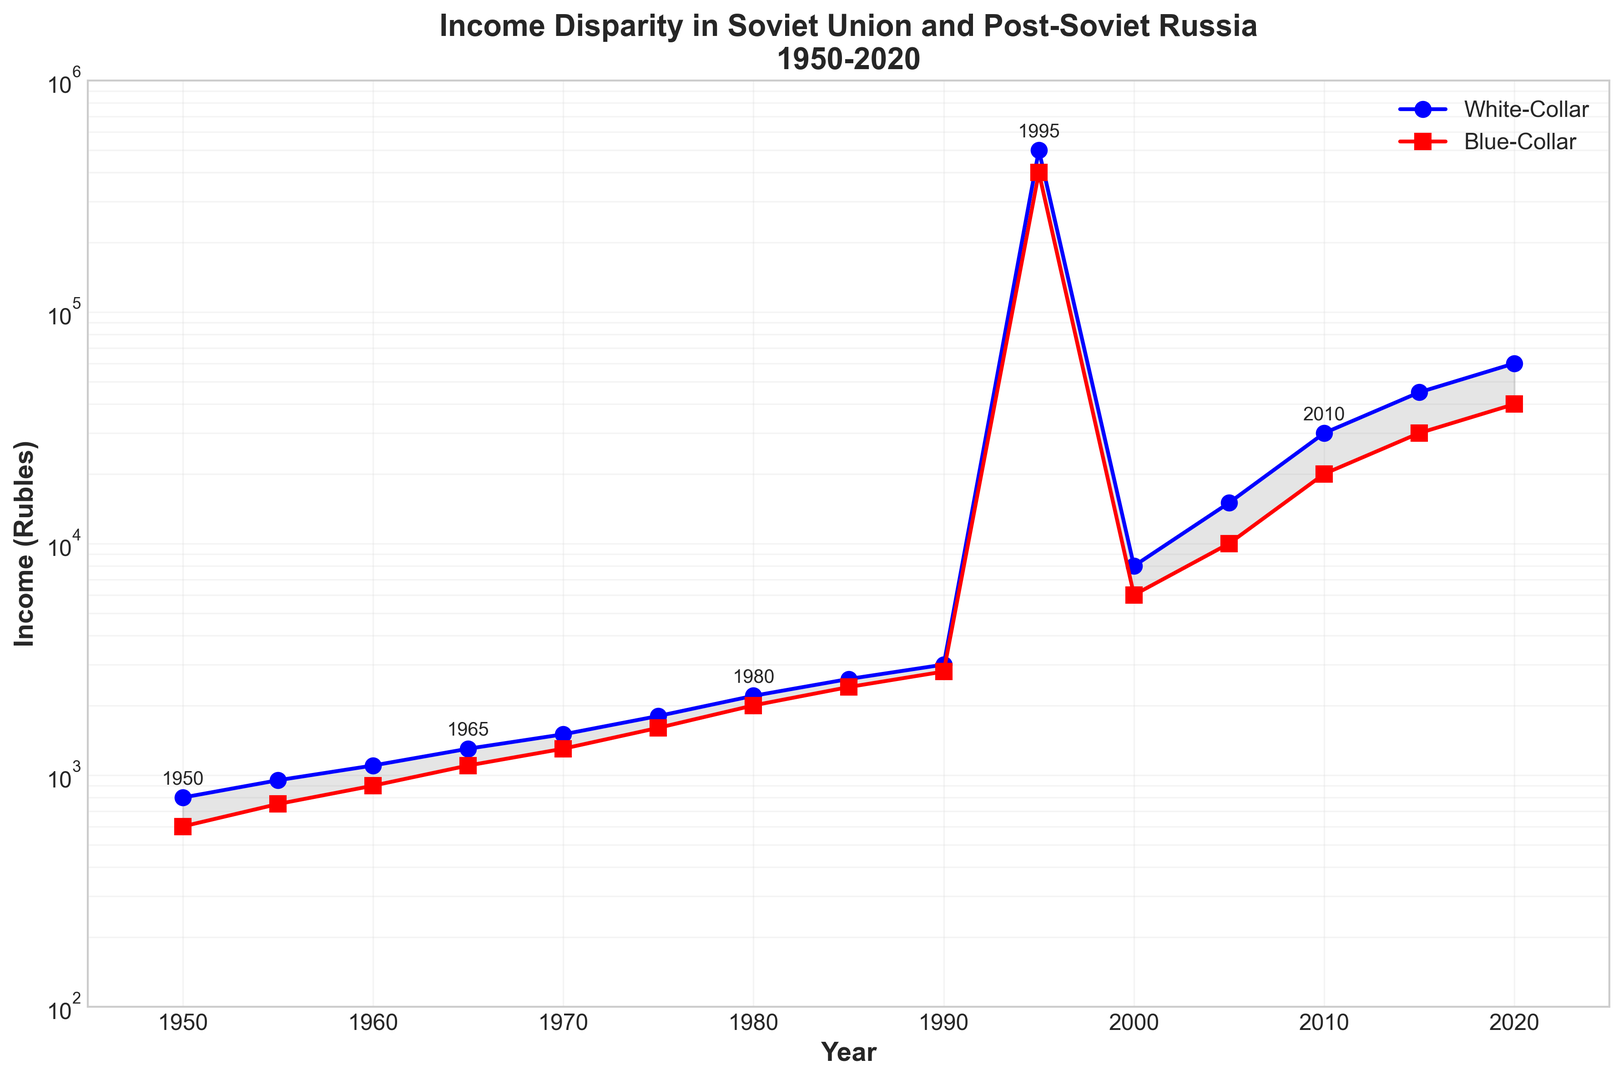What trends do you observe in the income disparity between white-collar and blue-collar workers from 1950 to 2020? The graph shows that both white-collar and blue-collar incomes increased over time, with a significant spike around 1995, coinciding with the post-Soviet era. Before 1995, the income disparity (difference between white-collar and blue-collar incomes) grew steadily but was relatively modest. After 1995, the income disparity widened much more significantly, indicating a larger gap between white-collar and blue-collar incomes in post-Soviet Russia.
Answer: The income disparity increased especially after 1995 During which period did the white-collar income see the most dramatic increase? By examining the slopes of the lines, the white-collar income saw the most dramatic increase between 1990 and 1995. This is indicated by the steep rise in the blue line (white-collar income) during this period.
Answer: 1990-1995 How much was the income disparity between white-collar and blue-collar workers in 2020? The white-collar income in 2020 was 60,000 rubles and the blue-collar income was 40,000 rubles. The income disparity is calculated as 60,000 - 40,000 = 20,000 rubles.
Answer: 20,000 rubles What was the ratio of white-collar to blue-collar income in 1970? The white-collar income in 1970 was 1500 rubles and the blue-collar income was 1300 rubles. The ratio is calculated as 1500 / 1300 ≈ 1.15.
Answer: 1.15 Identify the year with the smallest income disparity between white-collar and blue-collar workers. By observing the gap between the blue and red lines, the smallest disparity occurred in 1955, where the incomes were 950 rubles for white-collar and 750 rubles for blue-collar workers. The difference is 950 - 750 = 200 rubles.
Answer: 1955 How did the income of blue-collar workers change from 1980 to 2000? The blue-collar income in 1980 was 2000 rubles and in 2000 it was 6000 rubles. The change can be calculated as 6000 - 2000 = 4000 rubles.
Answer: Increased by 4000 rubles Compare the percentage increase in white-collar income to blue-collar income from 2015 to 2020. The white-collar income increased from 45000 to 60000 rubles, which is (60000-45000)/45000 * 100 ≈ 33.33%. The blue-collar income increased from 30000 to 40000 rubles, which is (40000-30000)/30000 * 100 ≈ 33.33%. Both percentages are approximately the same.
Answer: 33.33% for both What visual elements help emphasize the income disparity on the graph? The fill between the two lines, the different colors (blue for white-collar and red for blue-collar), and the semilogarithmic scale help emphasize the income disparity. This highlight is a shaded area between the lines, clear color differentiation, and log scale to show larger disparities distinctly.
Answer: Fill between the lines, colors, log scale Is there any period where the income levels for both groups appear to remain relatively stable? Between 1950 and 1985, the incomes of both white-collar and blue-collar workers show a gradual and more stable rise compared to the steep increases observed post-1990. The lines are smoother with smaller increments during this earlier period.
Answer: 1950-1985 What can be inferred from the graph about how economic transitions affected income levels in Russia? The graph shows a sharp increase in income levels around the post-Soviet transition (early 1990s), suggesting significant economic changes during this period. Before this, the increases are more gradual, indicating stability in the Soviet period. The rapid increases post-1990 reflect economic upheavals and transitions in the market dynamics.
Answer: Post-Soviet transition led to rapid income changes 